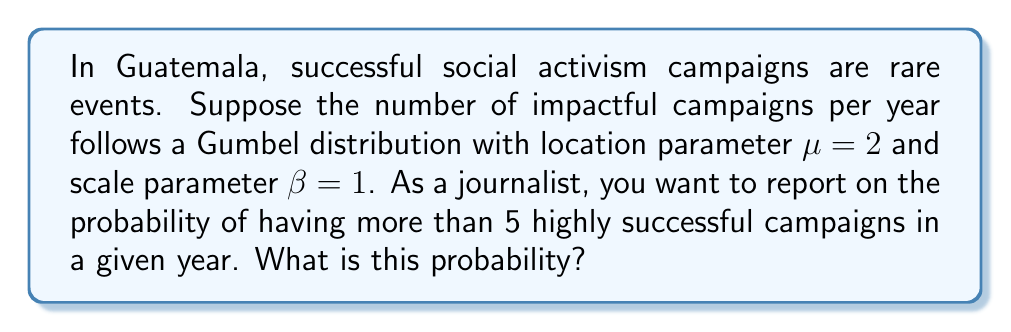Solve this math problem. To solve this problem, we'll use the cumulative distribution function (CDF) of the Gumbel distribution and apply extreme value theory concepts.

Step 1: Recall the CDF of the Gumbel distribution:
$$F(x; \mu, \beta) = e^{-e^{-(x-\mu)/\beta}}$$

Step 2: We want to find $P(X > 5)$, which is equivalent to $1 - P(X \leq 5)$:
$$P(X > 5) = 1 - F(5; \mu, \beta)$$

Step 3: Substitute the given values $\mu = 2$, $\beta = 1$, and $x = 5$:
$$P(X > 5) = 1 - e^{-e^{-(5-2)/1}}$$

Step 4: Simplify the expression:
$$P(X > 5) = 1 - e^{-e^{-3}}$$

Step 5: Calculate the result:
$$P(X > 5) \approx 1 - 0.9502 = 0.0498$$

Step 6: Convert to a percentage:
$$0.0498 \times 100\% = 4.98\%$$

This result indicates that the probability of having more than 5 highly successful social activism campaigns in a given year is approximately 4.98%.
Answer: 4.98% 